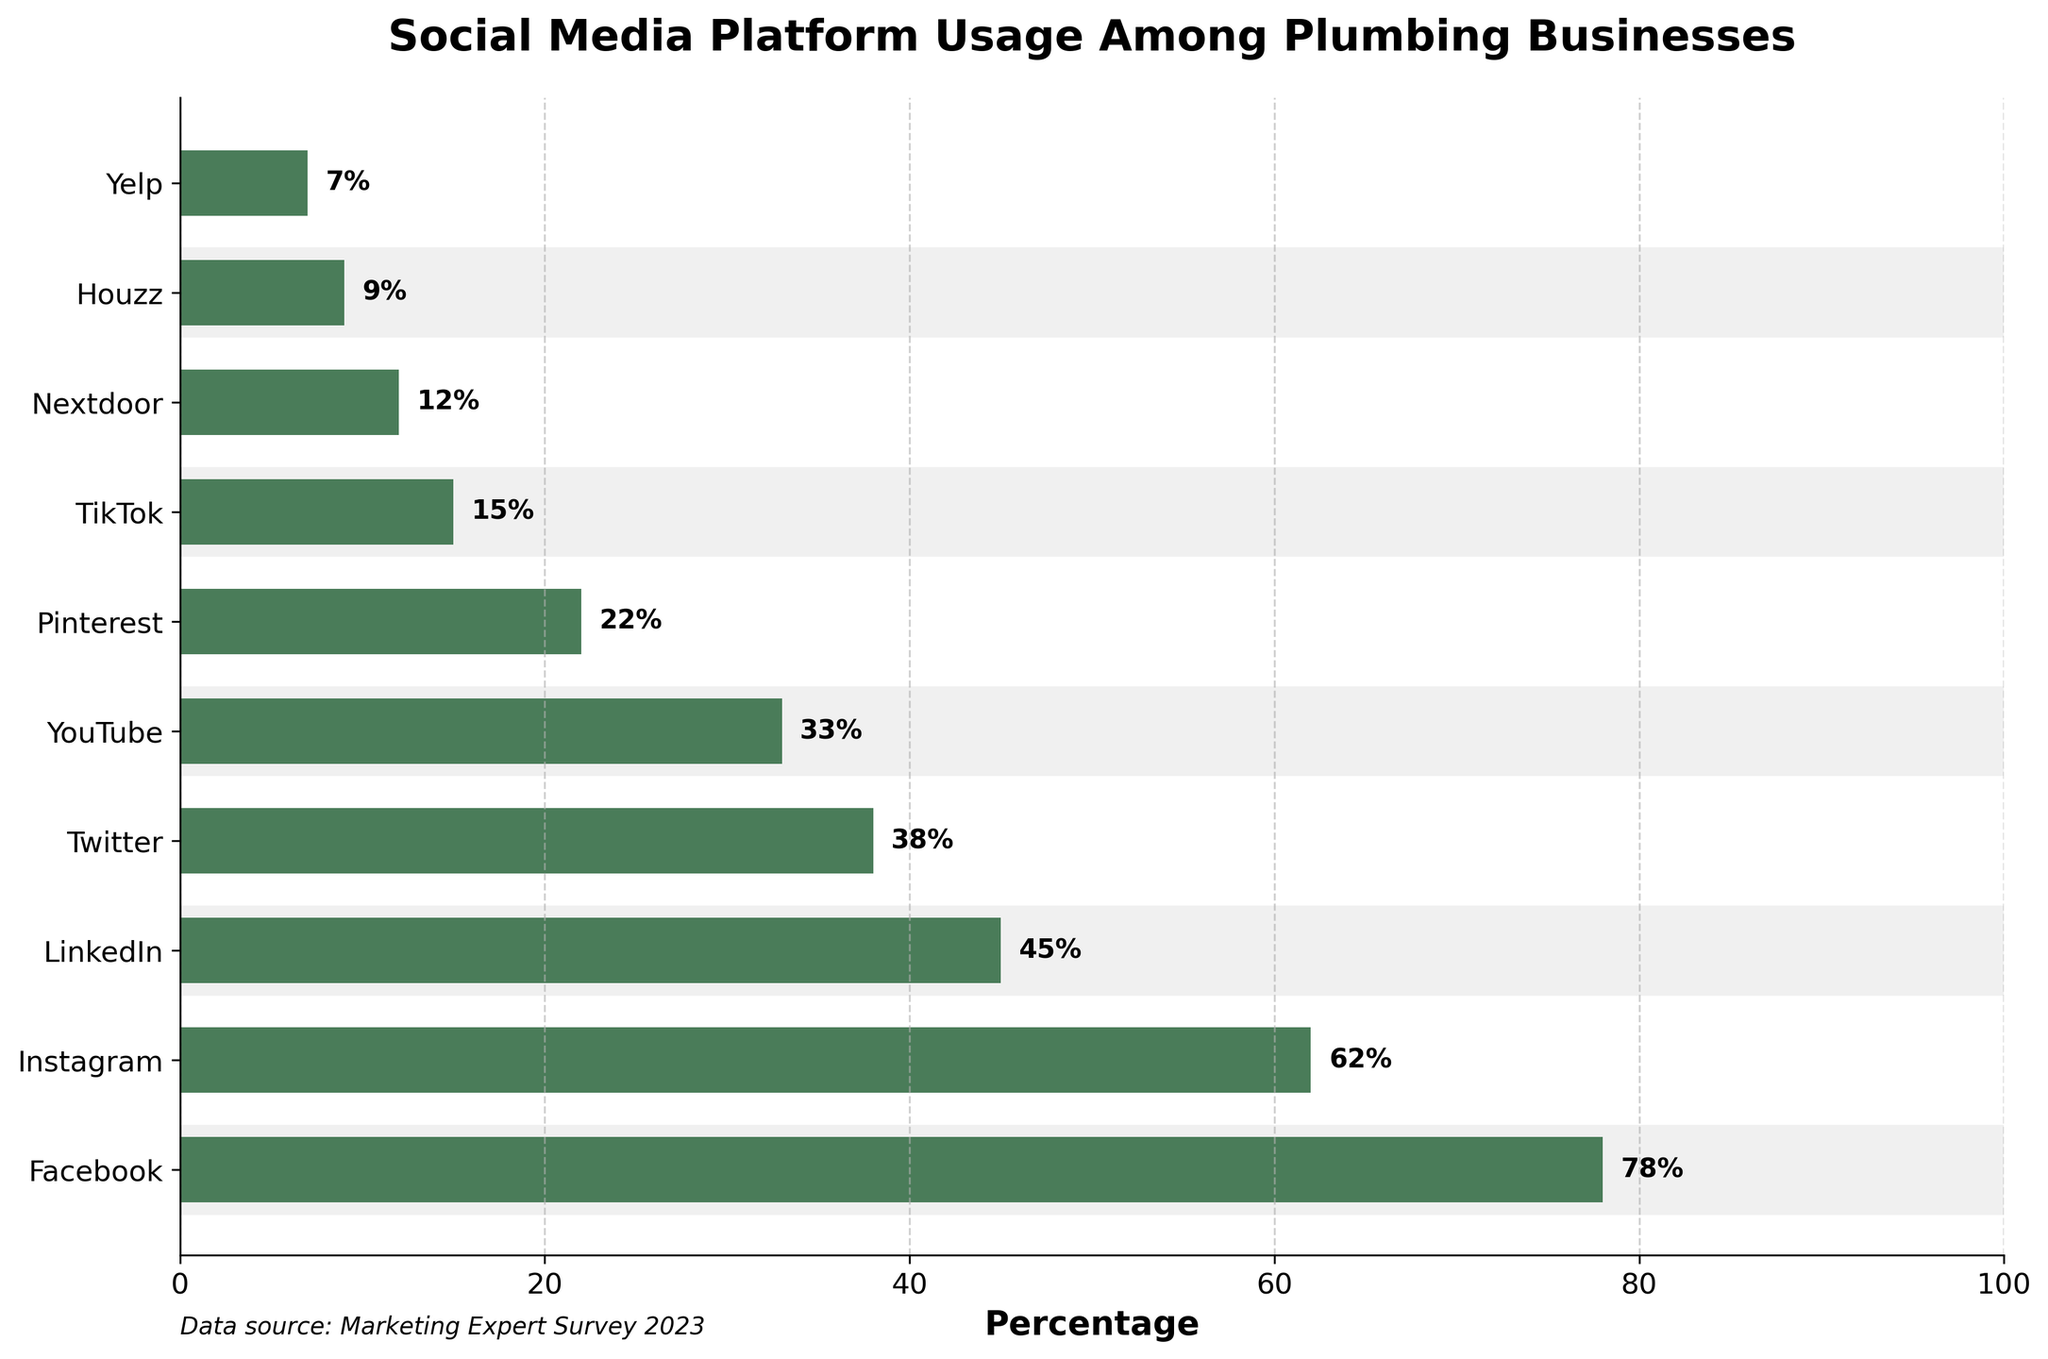Which social media platform is used the most by plumbing businesses? The bar representing Facebook is the longest, indicating that it has the highest usage percentage among plumbing businesses at 78%.
Answer: Facebook Which platform has a greater usage percentage, Twitter or LinkedIn? By visually comparing the lengths of the bars, LinkedIn's bar is longer than Twitter's. LinkedIn has a usage percentage of 45%, while Twitter has 38%.
Answer: LinkedIn What is the combined usage percentage of YouTube and Pinterest? Adding the percentages of YouTube (33%) and Pinterest (22%), the combined usage is 33 + 22 = 55.
Answer: 55% Which platform has the least usage among plumbing businesses? Yelp has the shortest bar in the chart, meaning it has the lowest usage percentage at 7%.
Answer: Yelp What is the difference in usage percentage between Facebook and Instagram? Subtracting the usage percentage of Instagram (62%) from that of Facebook (78%), the difference is 78 - 62 = 16.
Answer: 16 How many platforms have a usage percentage higher than 40%? The platforms with percentages higher than 40% are Facebook (78%), Instagram (62%), and LinkedIn (45%), totaling 3 platforms.
Answer: 3 Which platform has approximately half the usage percentage of Instagram? By evaluating the bars’ lengths and percentages, YouTube has 33%, which is roughly half of Instagram's 62%.
Answer: YouTube Is the usage percentage of TikTok more than double that of Yelp? TikTok has a usage percentage of 15%, and Yelp has 7%. 7 doubled is 14, and 15 is indeed greater than 14.
Answer: Yes What is the average usage percentage of Facebook, LinkedIn, and Twitter? Adding the percentages of Facebook (78%), LinkedIn (45%), and Twitter (38%) and then dividing by 3 gives (78 + 45 + 38) / 3 = 161 / 3 ≈ 53.67.
Answer: 53.67% Among Nextdoor and Houzz, which has a lower usage percentage and by how much? Nextdoor has 12%, and Houzz has 9%. The difference is 12 - 9 = 3, so Houzz has a lower usage by 3 percentage points.
Answer: Houzz, 3 